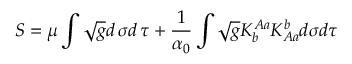Convert formula to latex. <formula><loc_0><loc_0><loc_500><loc_500>S = \mu \int \sqrt { g } d \, \sigma d \, \tau + \frac { 1 } { \alpha _ { 0 } } \int \sqrt { g } K _ { b } ^ { A a } K _ { A a } ^ { b } d \sigma d \tau</formula> 